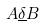<formula> <loc_0><loc_0><loc_500><loc_500>A \underline { \delta } B</formula> 